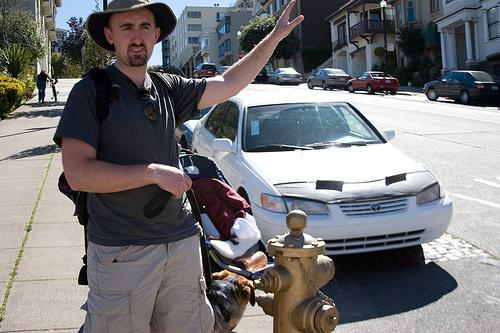Write a brief scene report inspired by the image. Man spotted waving on the sidewalk next to a parked white Toyota Camry and a dull yellow fire hydrant in a city block setting. Summarize the image in a simple, straightforward sentence. A man in casual clothing stands waving on a sidewalk near a white parked car and a yellow fire hydrant. Describe the key elements of the image in a short sentence. A man dressed in beige pants and a grey shirt waves on a paved sidewalk near a parked white car and a yellow fire hydrant. Identify the main focal points of the image and describe their appearance. There is a white Toyota Camry parked on the street, a man wearing beige pants and a dark grey t-shirt waving on the sidewalk, and a dull yellow fire hydrant nearby. Construct a short narrative about the events captured in the image. A friendly man, dressed casually in beige pants and a dark grey shirt, waves to a passerby while standing on a city sidewalk near a parked white Toyota Camry and a dull yellow fire hydrant. What is the general atmosphere and scene depicted in the image? The image shows a casual city scene with a man in beige pants and a grey shirt waving on the sidewalk near a parked white Toyota Camry and a dull yellow fire hydrant. Detail the key subjects and their actions in the image. A casually-dressed man standing on the sidewalk, waving near a parked white Toyota Camry and a dull yellow fire hydrant. Provide a simple description of the scene in the image. A man in casual attire is waving on the sidewalk near parked cars and a yellow fire hydrant. Concisely describe the main figures and objects in the image. A man in beige pants and grey t-shirt waving, a white Toyota Camry parked on the street, and a dull yellow fire hydrant. Mention the notable objects and individuals present in the image. The image features a waving man wearing beige pants and a grey shirt, a parked white Toyota Camry, and a yellow fire hydrant on the sidewalk. 